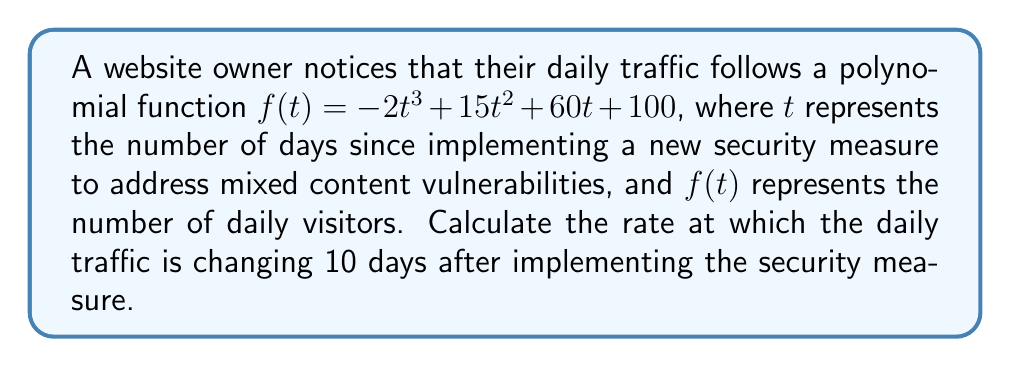Show me your answer to this math problem. To solve this problem, we need to follow these steps:

1. Recognize that the rate of change is represented by the derivative of the function.
2. Find the derivative of the given polynomial function.
3. Evaluate the derivative at $t = 10$.

Step 1: The rate of change is given by the derivative of the function.

Step 2: Let's find the derivative of $f(t) = -2t^3 + 15t^2 + 60t + 100$

Using the power rule and the constant rule of differentiation:

$f'(t) = \frac{d}{dt}(-2t^3) + \frac{d}{dt}(15t^2) + \frac{d}{dt}(60t) + \frac{d}{dt}(100)$

$f'(t) = -6t^2 + 30t + 60 + 0$

$f'(t) = -6t^2 + 30t + 60$

Step 3: Evaluate $f'(t)$ at $t = 10$

$f'(10) = -6(10)^2 + 30(10) + 60$

$f'(10) = -6(100) + 300 + 60$

$f'(10) = -600 + 300 + 60$

$f'(10) = -240$

The negative value indicates that the traffic is decreasing at this point.
Answer: The rate at which the daily traffic is changing 10 days after implementing the security measure is $-240$ visitors per day. 